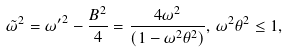Convert formula to latex. <formula><loc_0><loc_0><loc_500><loc_500>\tilde { \omega } ^ { 2 } = { \omega ^ { \prime } } ^ { 2 } - \frac { B ^ { 2 } } { 4 } = \frac { 4 \omega ^ { 2 } } { ( 1 - \omega ^ { 2 } \theta ^ { 2 } ) } , \, \omega ^ { 2 } \theta ^ { 2 } \leq 1 ,</formula> 